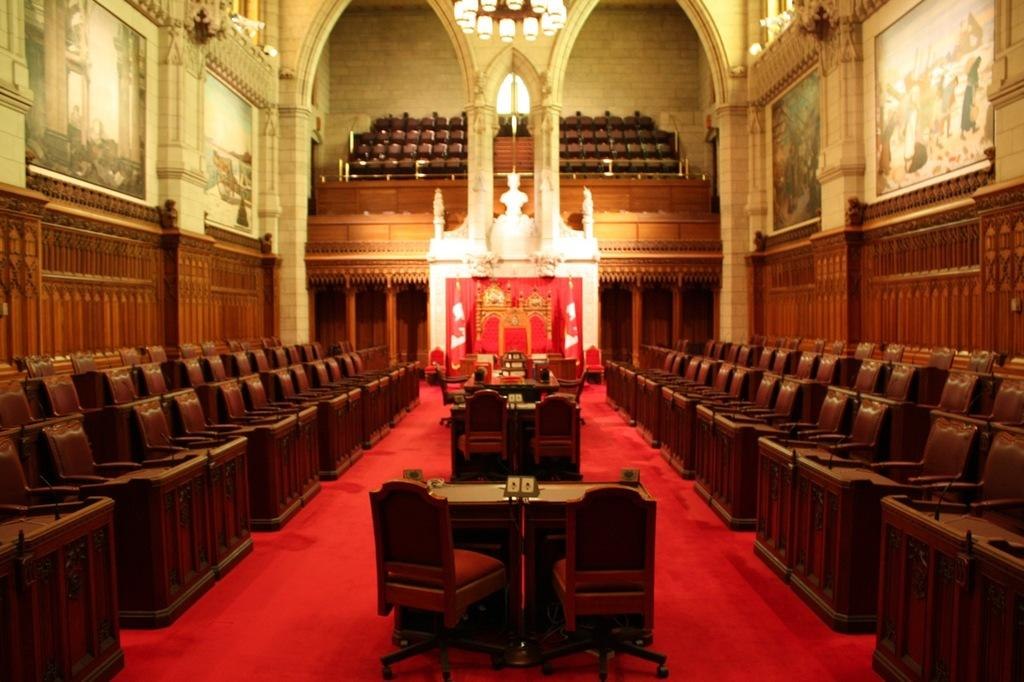What type of location is depicted in the image? The image shows the inside of a building. What furniture is present in the image? There are chairs and tables in the image. What decorative elements can be seen on the walls in the image? There are frames on the wall in the image. What type of lighting is visible in the image? There are lights visible in the image. What type of path is present in the image? There is a path in the image. What invention is being demonstrated by the friends in the image? There are no friends or inventions present in the image; it shows the inside of a building with furniture and decorative elements. 